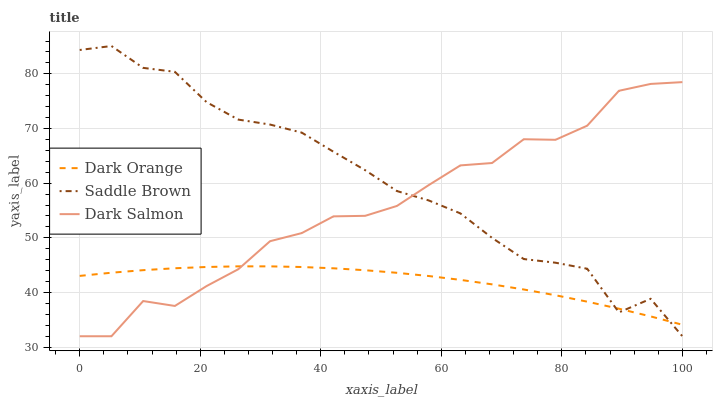Does Dark Orange have the minimum area under the curve?
Answer yes or no. Yes. Does Saddle Brown have the maximum area under the curve?
Answer yes or no. Yes. Does Dark Salmon have the minimum area under the curve?
Answer yes or no. No. Does Dark Salmon have the maximum area under the curve?
Answer yes or no. No. Is Dark Orange the smoothest?
Answer yes or no. Yes. Is Dark Salmon the roughest?
Answer yes or no. Yes. Is Saddle Brown the smoothest?
Answer yes or no. No. Is Saddle Brown the roughest?
Answer yes or no. No. Does Saddle Brown have the lowest value?
Answer yes or no. Yes. Does Saddle Brown have the highest value?
Answer yes or no. Yes. Does Dark Salmon have the highest value?
Answer yes or no. No. Does Dark Orange intersect Dark Salmon?
Answer yes or no. Yes. Is Dark Orange less than Dark Salmon?
Answer yes or no. No. Is Dark Orange greater than Dark Salmon?
Answer yes or no. No. 